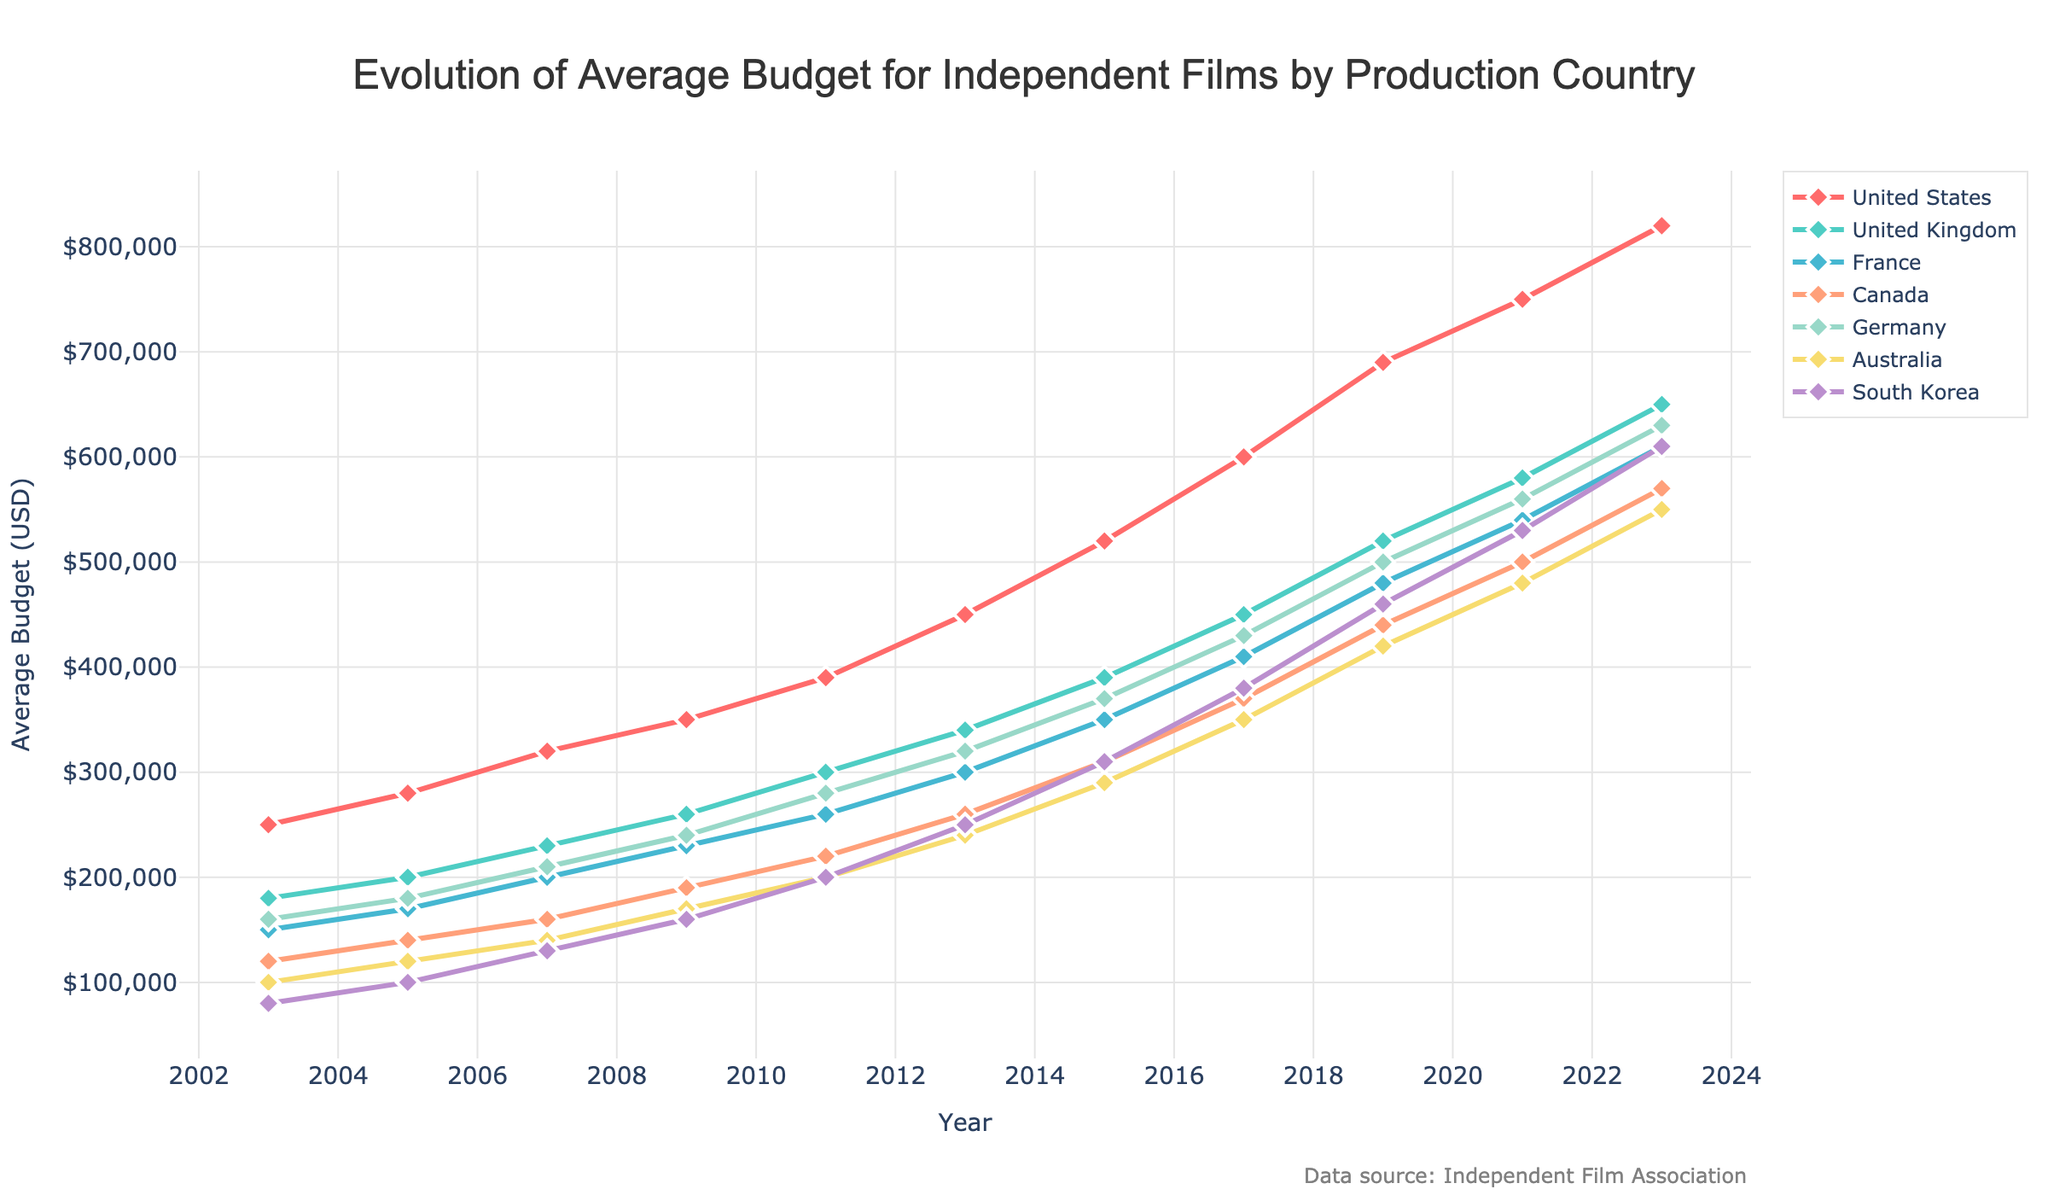What is the average budget for independent films in the United States in 2023? The chart shows the average budget for each country by year. For the United States in 2023, locate the line labeled "United States" at the year 2023. The value is $820,000.
Answer: $820,000 Which country had the lowest average budget for independent films in 2003? Look for the year 2003 and compare the endpoints of all lines. The line with the lowest value corresponds to South Korea, with a budget of $80,000.
Answer: South Korea Between 2005 and 2011, which country's average budget increased the most? Calculate the difference between 2011 and 2005 values for each country. The differences are: US = 390k-280k = 110k, UK = 300k-200k = 100k, France = 260k-170k = 90k, Canada = 220k-140k = 80k, Germany = 280k-180k = 100k, Australia = 200k-120k = 80k, South Korea = 200k-100k = 100k. The United States had the greatest increase of 110k.
Answer: United States In 2019, how many countries had an average budget above $500,000? Check the data values for each country in 2019. The United States, United Kingdom, and France have budgets above $500,000. Thus, 3 countries have average budgets above $500,000 in 2019.
Answer: 3 Which country showed the steadiest increase in their average budget over the 20 years? Examine the slopes and consistency of the lines for each country. The United States shows the most steady and consistent increase without major fluctuation from 250k in 2003 to 820k in 2023.
Answer: United States What was the average budget increase for independent films in Australia from 2011 to 2017? Subtract the 2011 value from the 2017 value for Australia. The values are: 350k (2017) - 200k (2011) = 150k.
Answer: $150,000 